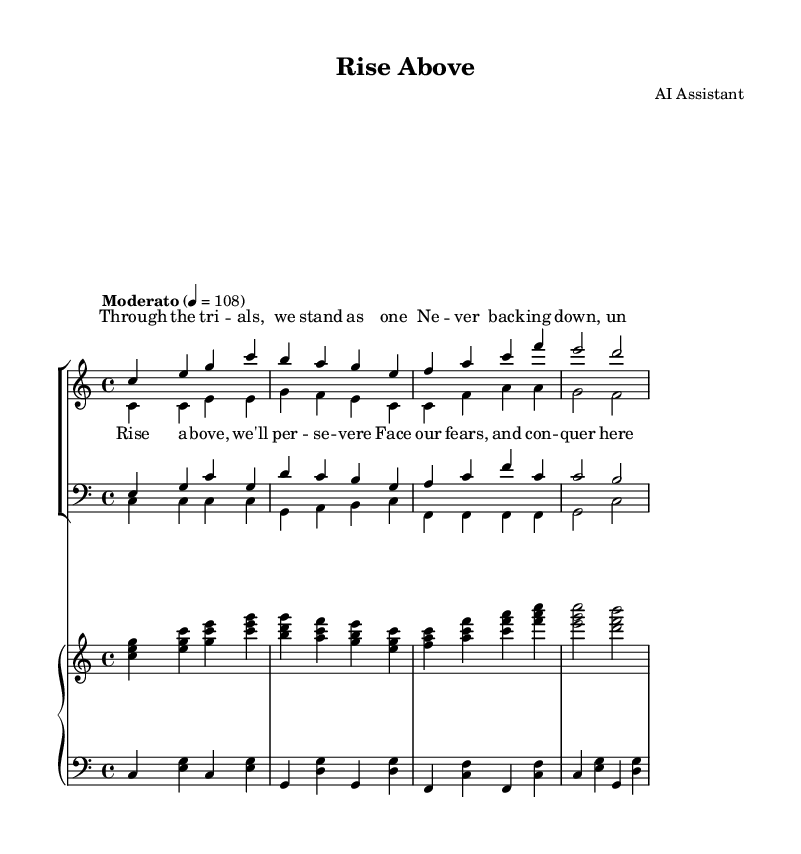What is the key signature of this music? The key signature is C major, which has no sharps or flats.
Answer: C major What is the time signature of the piece? The time signature is indicated at the beginning of the staff and shows that there are four beats in each measure.
Answer: 4/4 What is the tempo marking for the piece? The tempo marking indicates that the piece should be played at a moderate pace, specifically at 108 beats per minute.
Answer: Moderato How many voices are in the choir part? By examining the score, we can see there are four distinct voice parts: sopranos, altos, tenors, and basses.
Answer: Four What is the main message expressed in the chorus? The chorus emphasizes themes of perseverance and resilience, suggesting a collective effort to overcome challenges.
Answer: Rise above, we'll persevere Which section of the piece has lyrics associated with it? The section where lyrics are provided corresponds to the "sopranos" staff, where the verses and chorus are displayed.
Answer: Sopranos What is the range of the soprano part? The soprano part starts from middle C and uses pitches that vary upwards, indicating its higher vocal range typically used in choral compositions.
Answer: c'' to c 